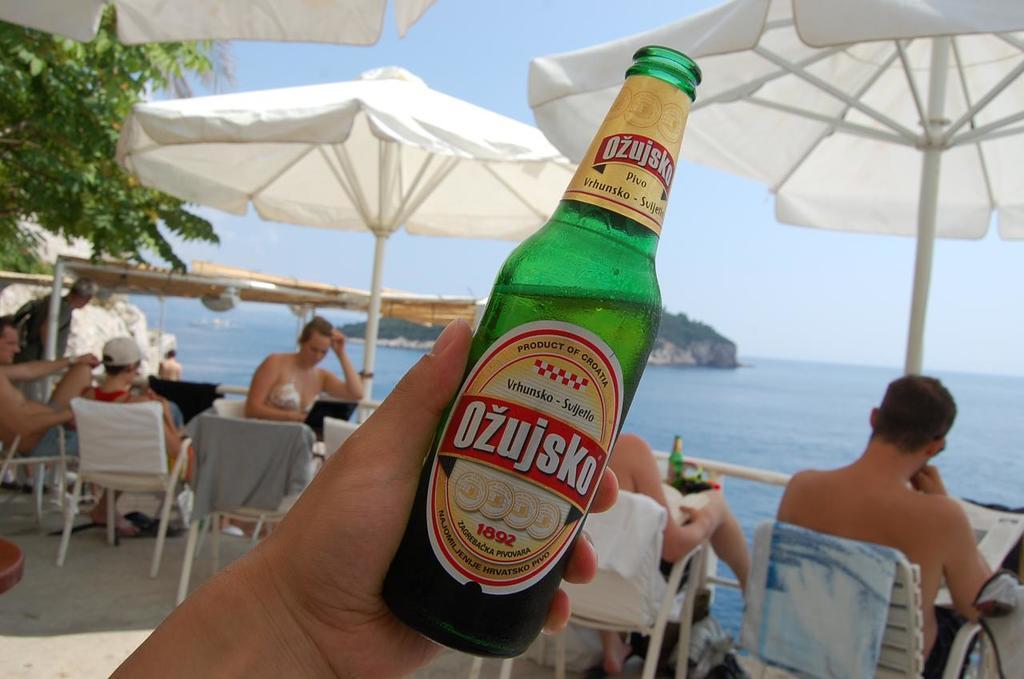In one or two sentences, can you explain what this image depicts? In the image we can see there are people who are sitting on the chair and in front there is an ocean and on the top there is an umbrella which is in white colour and in front there is a green colour wine bottle which a person is holding in his hand. 